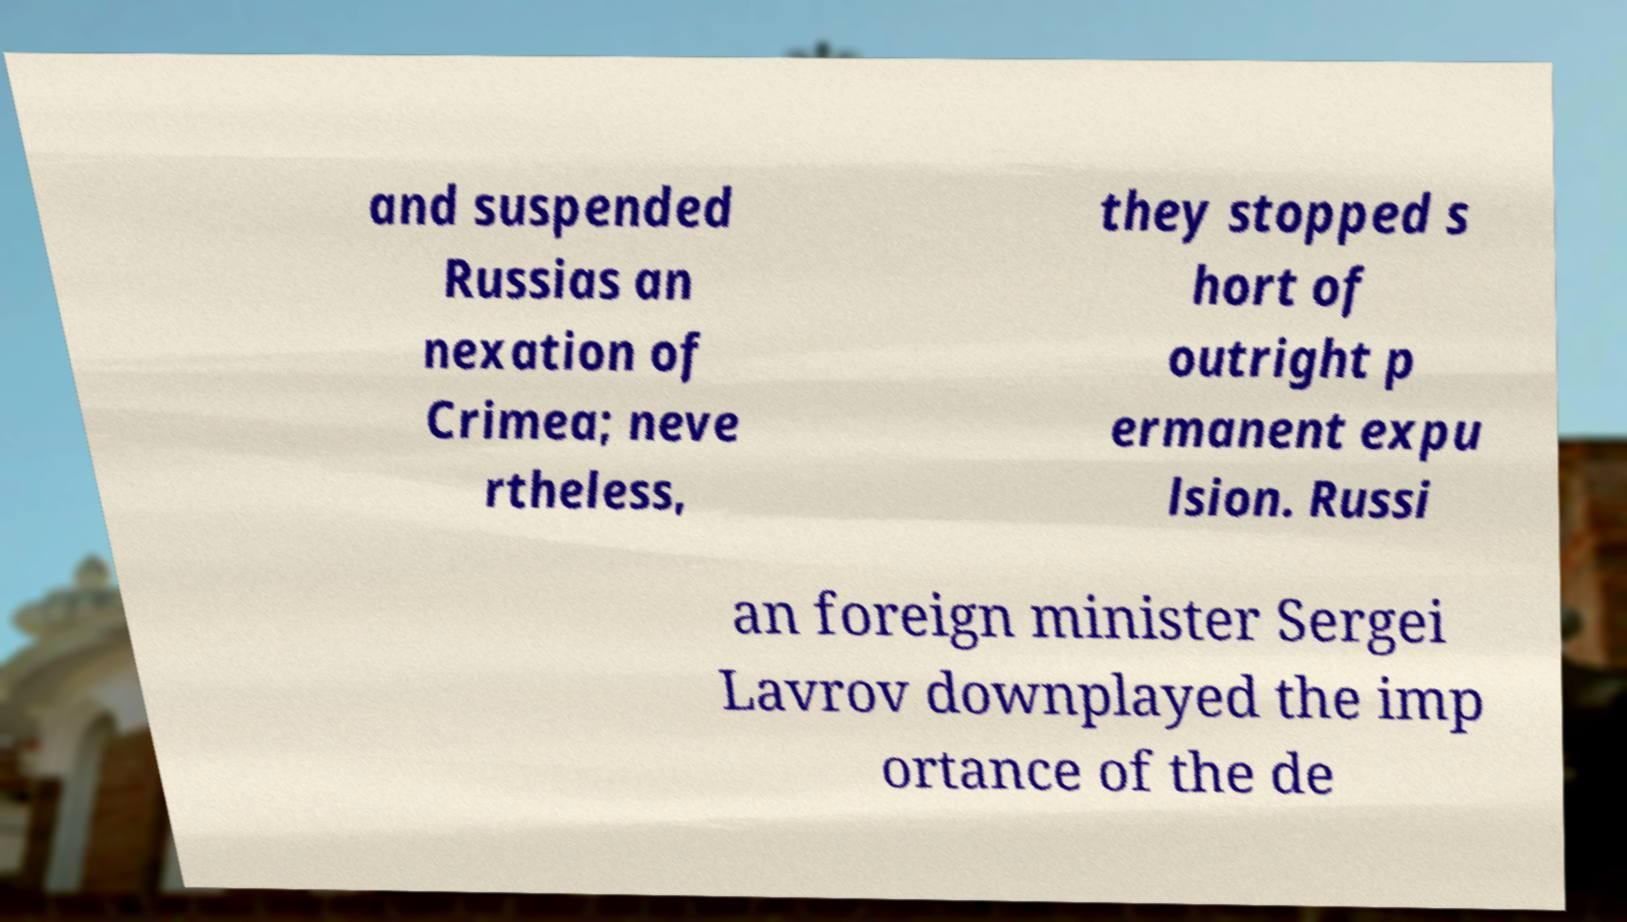Can you read and provide the text displayed in the image?This photo seems to have some interesting text. Can you extract and type it out for me? and suspended Russias an nexation of Crimea; neve rtheless, they stopped s hort of outright p ermanent expu lsion. Russi an foreign minister Sergei Lavrov downplayed the imp ortance of the de 